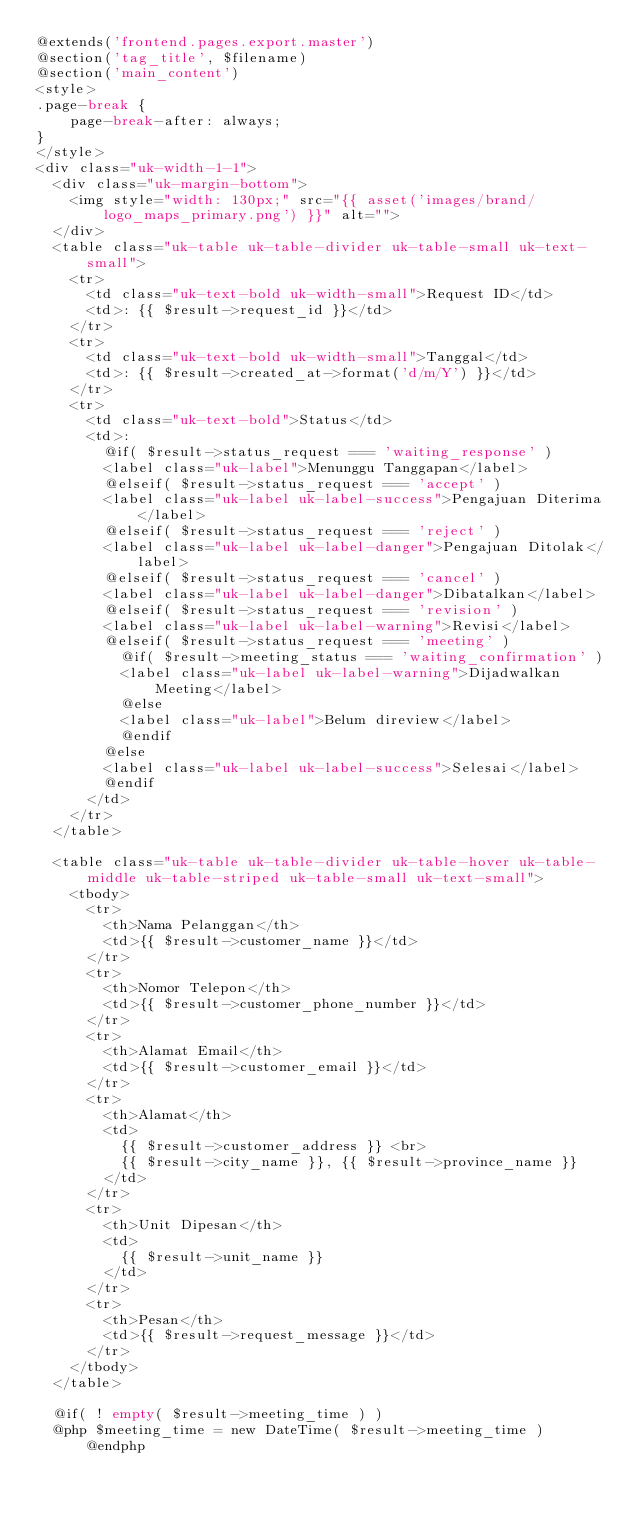<code> <loc_0><loc_0><loc_500><loc_500><_PHP_>@extends('frontend.pages.export.master')
@section('tag_title', $filename)
@section('main_content')
<style>
.page-break {
    page-break-after: always;
}
</style>
<div class="uk-width-1-1">
  <div class="uk-margin-bottom">
    <img style="width: 130px;" src="{{ asset('images/brand/logo_maps_primary.png') }}" alt="">
  </div>
  <table class="uk-table uk-table-divider uk-table-small uk-text-small">
    <tr>
      <td class="uk-text-bold uk-width-small">Request ID</td>
      <td>: {{ $result->request_id }}</td>
    </tr>
    <tr>
      <td class="uk-text-bold uk-width-small">Tanggal</td>
      <td>: {{ $result->created_at->format('d/m/Y') }}</td>
    </tr>
    <tr>
      <td class="uk-text-bold">Status</td>
      <td>:
        @if( $result->status_request === 'waiting_response' )
        <label class="uk-label">Menunggu Tanggapan</label>
        @elseif( $result->status_request === 'accept' )
        <label class="uk-label uk-label-success">Pengajuan Diterima</label>
        @elseif( $result->status_request === 'reject' )
        <label class="uk-label uk-label-danger">Pengajuan Ditolak</label>
        @elseif( $result->status_request === 'cancel' )
        <label class="uk-label uk-label-danger">Dibatalkan</label>
        @elseif( $result->status_request === 'revision' )
        <label class="uk-label uk-label-warning">Revisi</label>
        @elseif( $result->status_request === 'meeting' )
          @if( $result->meeting_status === 'waiting_confirmation' )
          <label class="uk-label uk-label-warning">Dijadwalkan Meeting</label>
          @else
          <label class="uk-label">Belum direview</label>
          @endif
        @else
        <label class="uk-label uk-label-success">Selesai</label>
        @endif
      </td>
    </tr>
  </table>

  <table class="uk-table uk-table-divider uk-table-hover uk-table-middle uk-table-striped uk-table-small uk-text-small">
    <tbody>
      <tr>
        <th>Nama Pelanggan</th>
        <td>{{ $result->customer_name }}</td>
      </tr>
      <tr>
        <th>Nomor Telepon</th>
        <td>{{ $result->customer_phone_number }}</td>
      </tr>
      <tr>
        <th>Alamat Email</th>
        <td>{{ $result->customer_email }}</td>
      </tr>
      <tr>
        <th>Alamat</th>
        <td>
          {{ $result->customer_address }} <br>
          {{ $result->city_name }}, {{ $result->province_name }}
        </td>
      </tr>
      <tr>
        <th>Unit Dipesan</th>
        <td>
          {{ $result->unit_name }}
        </td>
      </tr>
      <tr>
        <th>Pesan</th>
        <td>{{ $result->request_message }}</td>
      </tr>
    </tbody>
  </table>

  @if( ! empty( $result->meeting_time ) )
  @php $meeting_time = new DateTime( $result->meeting_time ) @endphp</code> 